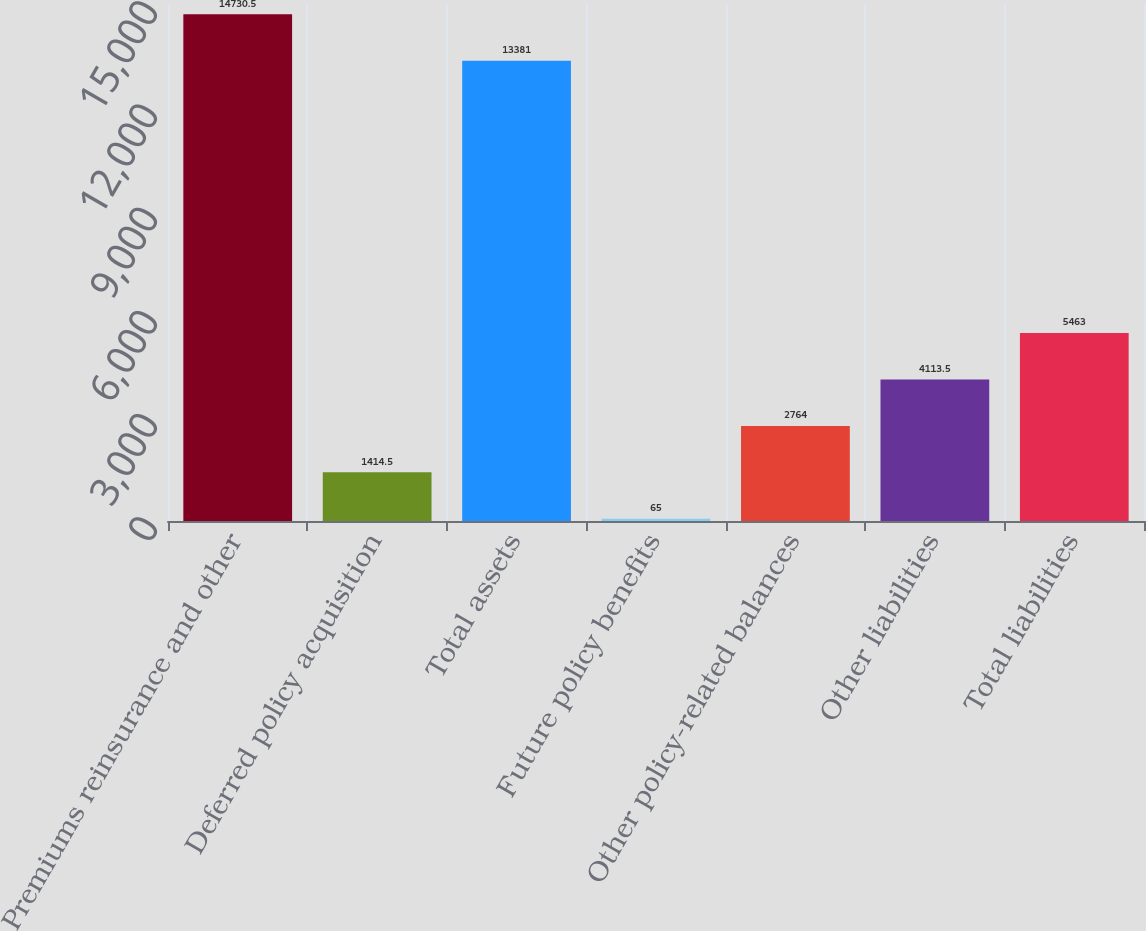Convert chart to OTSL. <chart><loc_0><loc_0><loc_500><loc_500><bar_chart><fcel>Premiums reinsurance and other<fcel>Deferred policy acquisition<fcel>Total assets<fcel>Future policy benefits<fcel>Other policy-related balances<fcel>Other liabilities<fcel>Total liabilities<nl><fcel>14730.5<fcel>1414.5<fcel>13381<fcel>65<fcel>2764<fcel>4113.5<fcel>5463<nl></chart> 